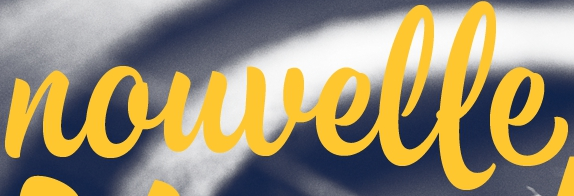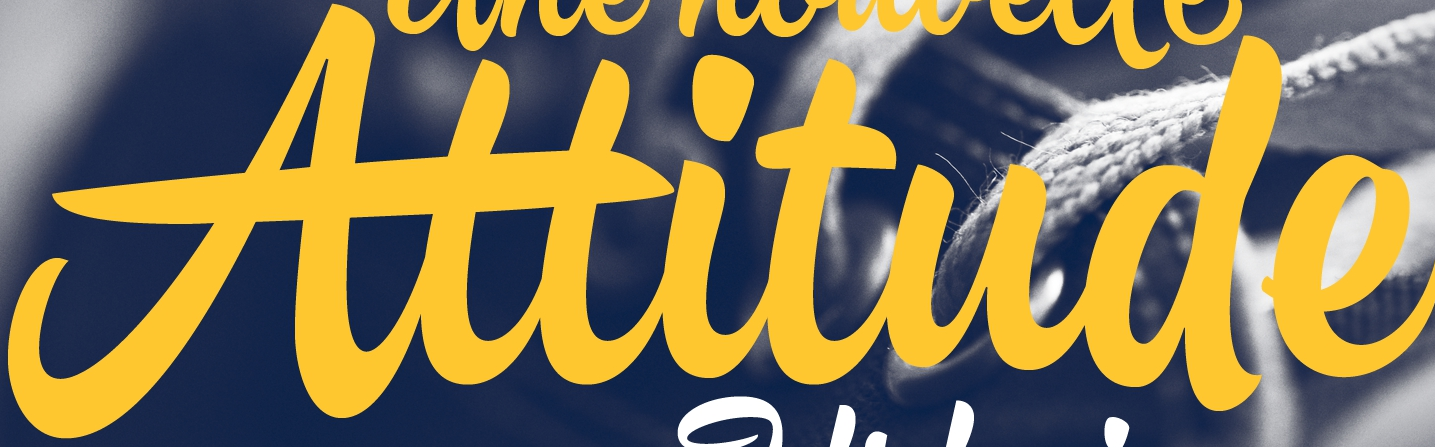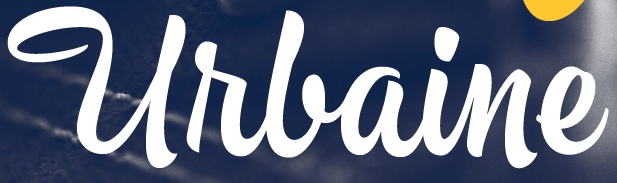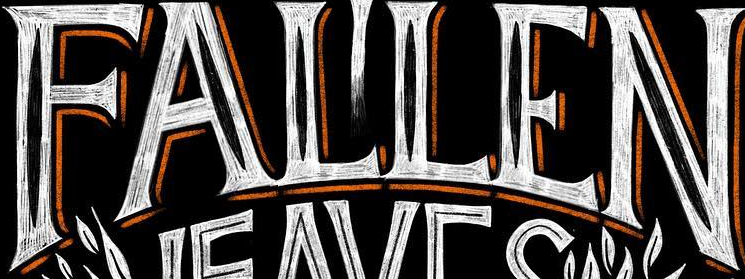What words are shown in these images in order, separated by a semicolon? nouvelle; Attitude; Urlaine; FALLEN 